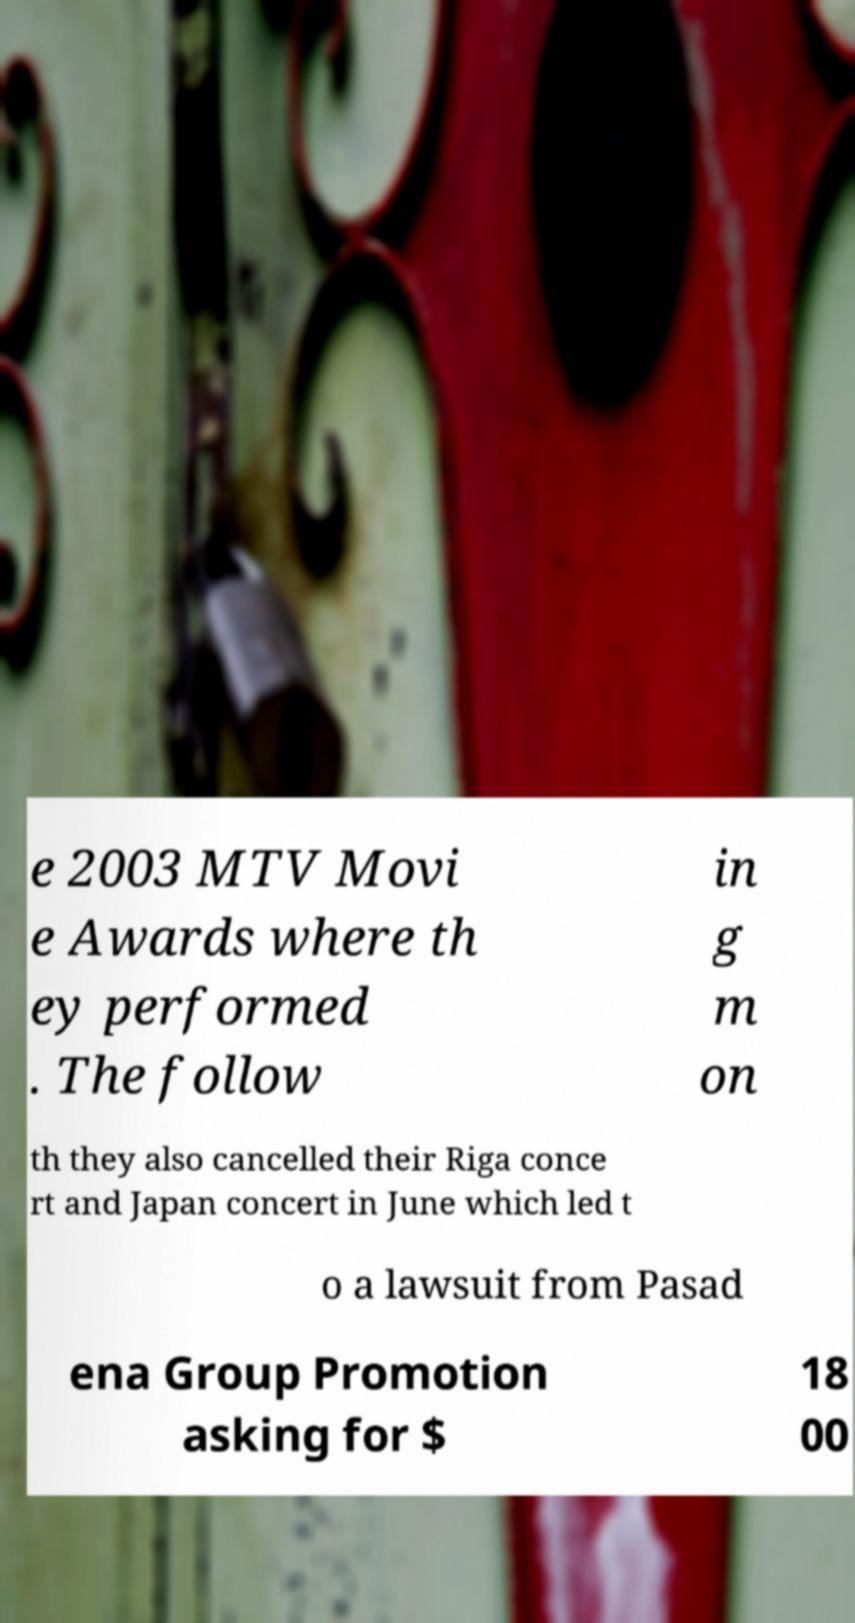What messages or text are displayed in this image? I need them in a readable, typed format. e 2003 MTV Movi e Awards where th ey performed . The follow in g m on th they also cancelled their Riga conce rt and Japan concert in June which led t o a lawsuit from Pasad ena Group Promotion asking for $ 18 00 